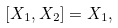Convert formula to latex. <formula><loc_0><loc_0><loc_500><loc_500>\left [ X _ { 1 } , X _ { 2 } \right ] = X _ { 1 } ,</formula> 